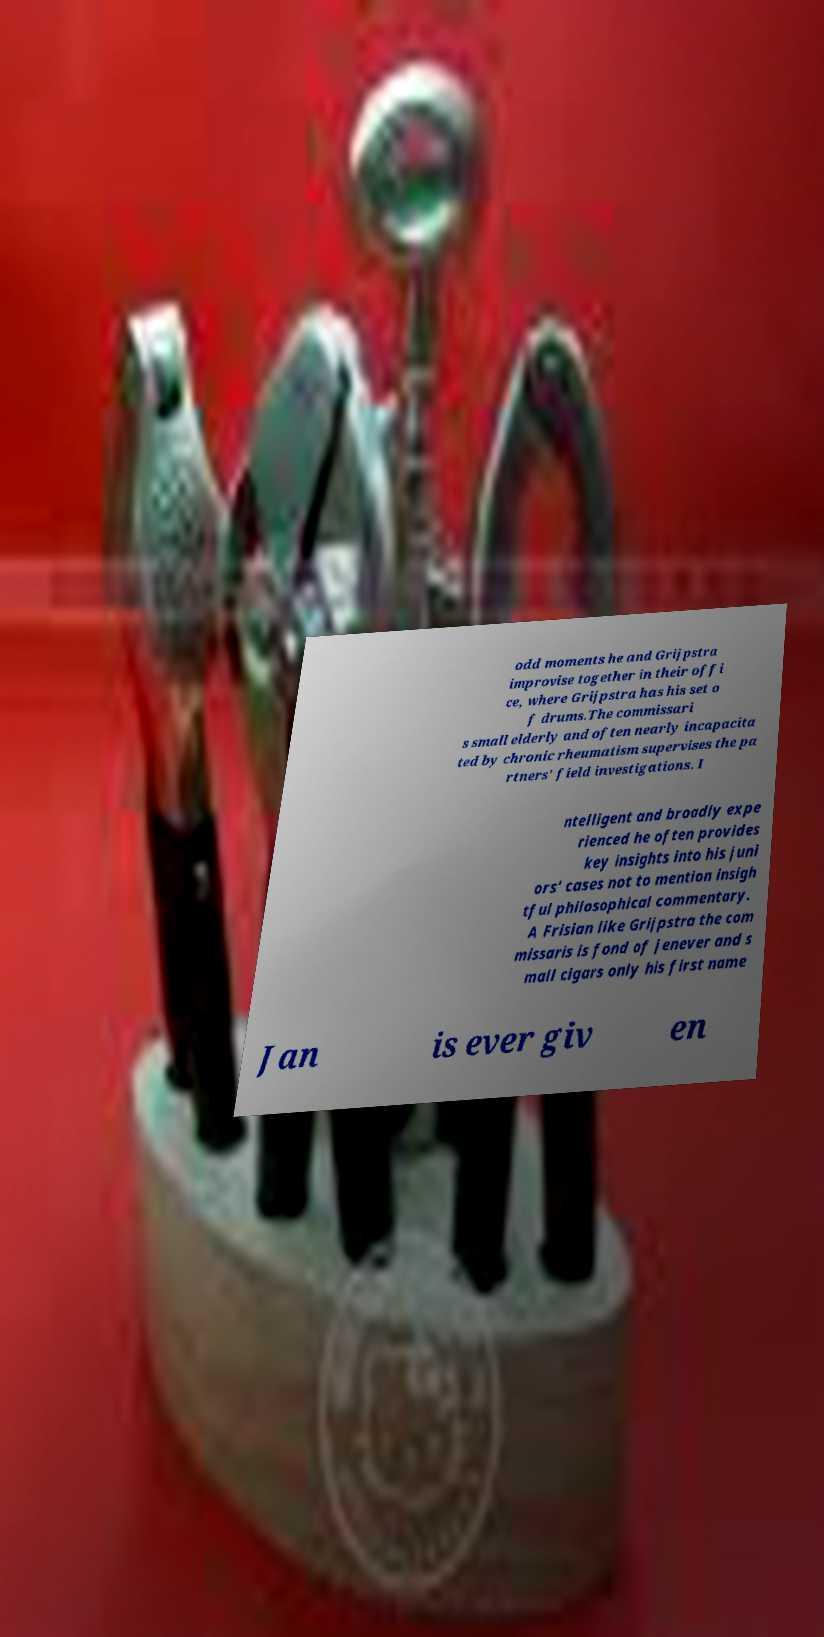There's text embedded in this image that I need extracted. Can you transcribe it verbatim? odd moments he and Grijpstra improvise together in their offi ce, where Grijpstra has his set o f drums.The commissari s small elderly and often nearly incapacita ted by chronic rheumatism supervises the pa rtners' field investigations. I ntelligent and broadly expe rienced he often provides key insights into his juni ors' cases not to mention insigh tful philosophical commentary. A Frisian like Grijpstra the com missaris is fond of jenever and s mall cigars only his first name Jan is ever giv en 